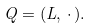<formula> <loc_0><loc_0><loc_500><loc_500>Q = ( L , \, \cdot \, ) .</formula> 